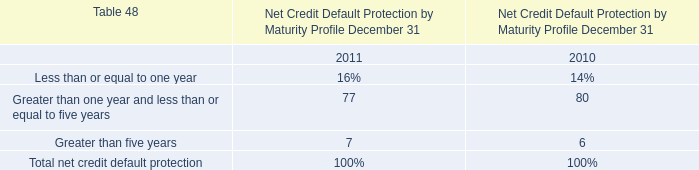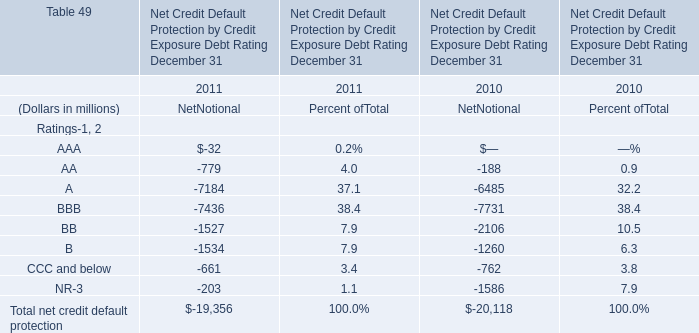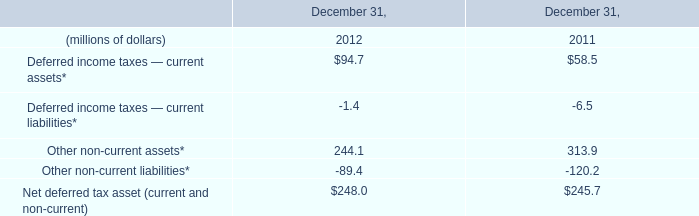What will Total net credit default protection reach in 2012 if it continues to grow at its current rate? (in million) 
Computations: (-19356 + ((-19356 * (-19356 + 20118)) / -20118))
Answer: -18622.86191. 